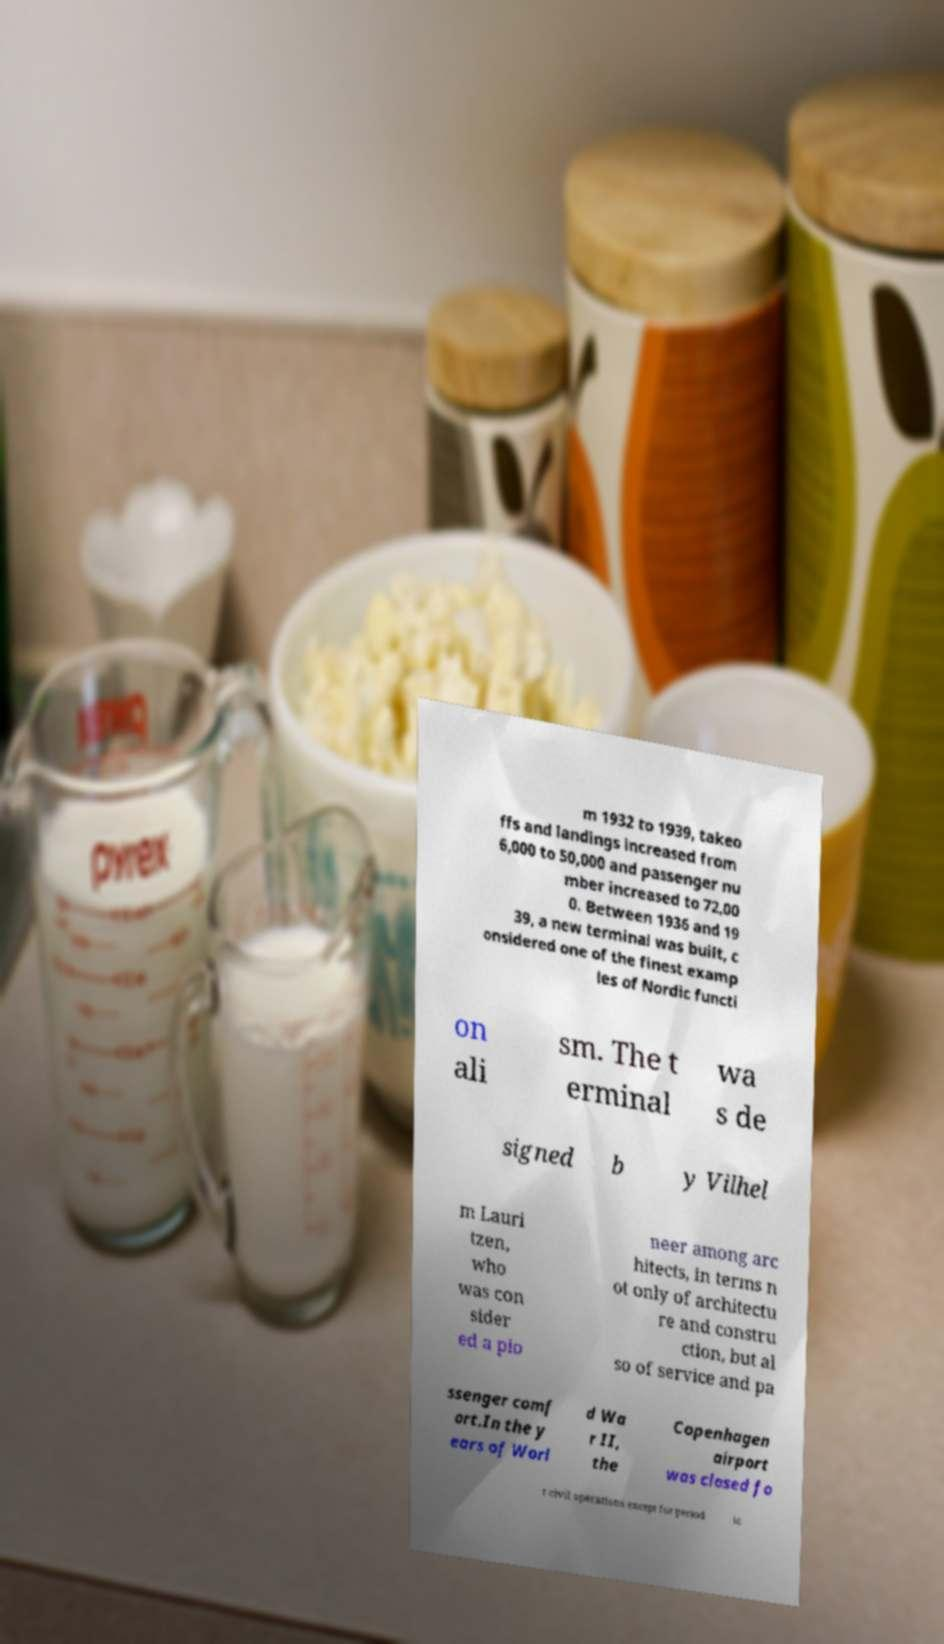Please identify and transcribe the text found in this image. m 1932 to 1939, takeo ffs and landings increased from 6,000 to 50,000 and passenger nu mber increased to 72,00 0. Between 1936 and 19 39, a new terminal was built, c onsidered one of the finest examp les of Nordic functi on ali sm. The t erminal wa s de signed b y Vilhel m Lauri tzen, who was con sider ed a pio neer among arc hitects, in terms n ot only of architectu re and constru ction, but al so of service and pa ssenger comf ort.In the y ears of Worl d Wa r II, the Copenhagen airport was closed fo r civil operations except for period ic 